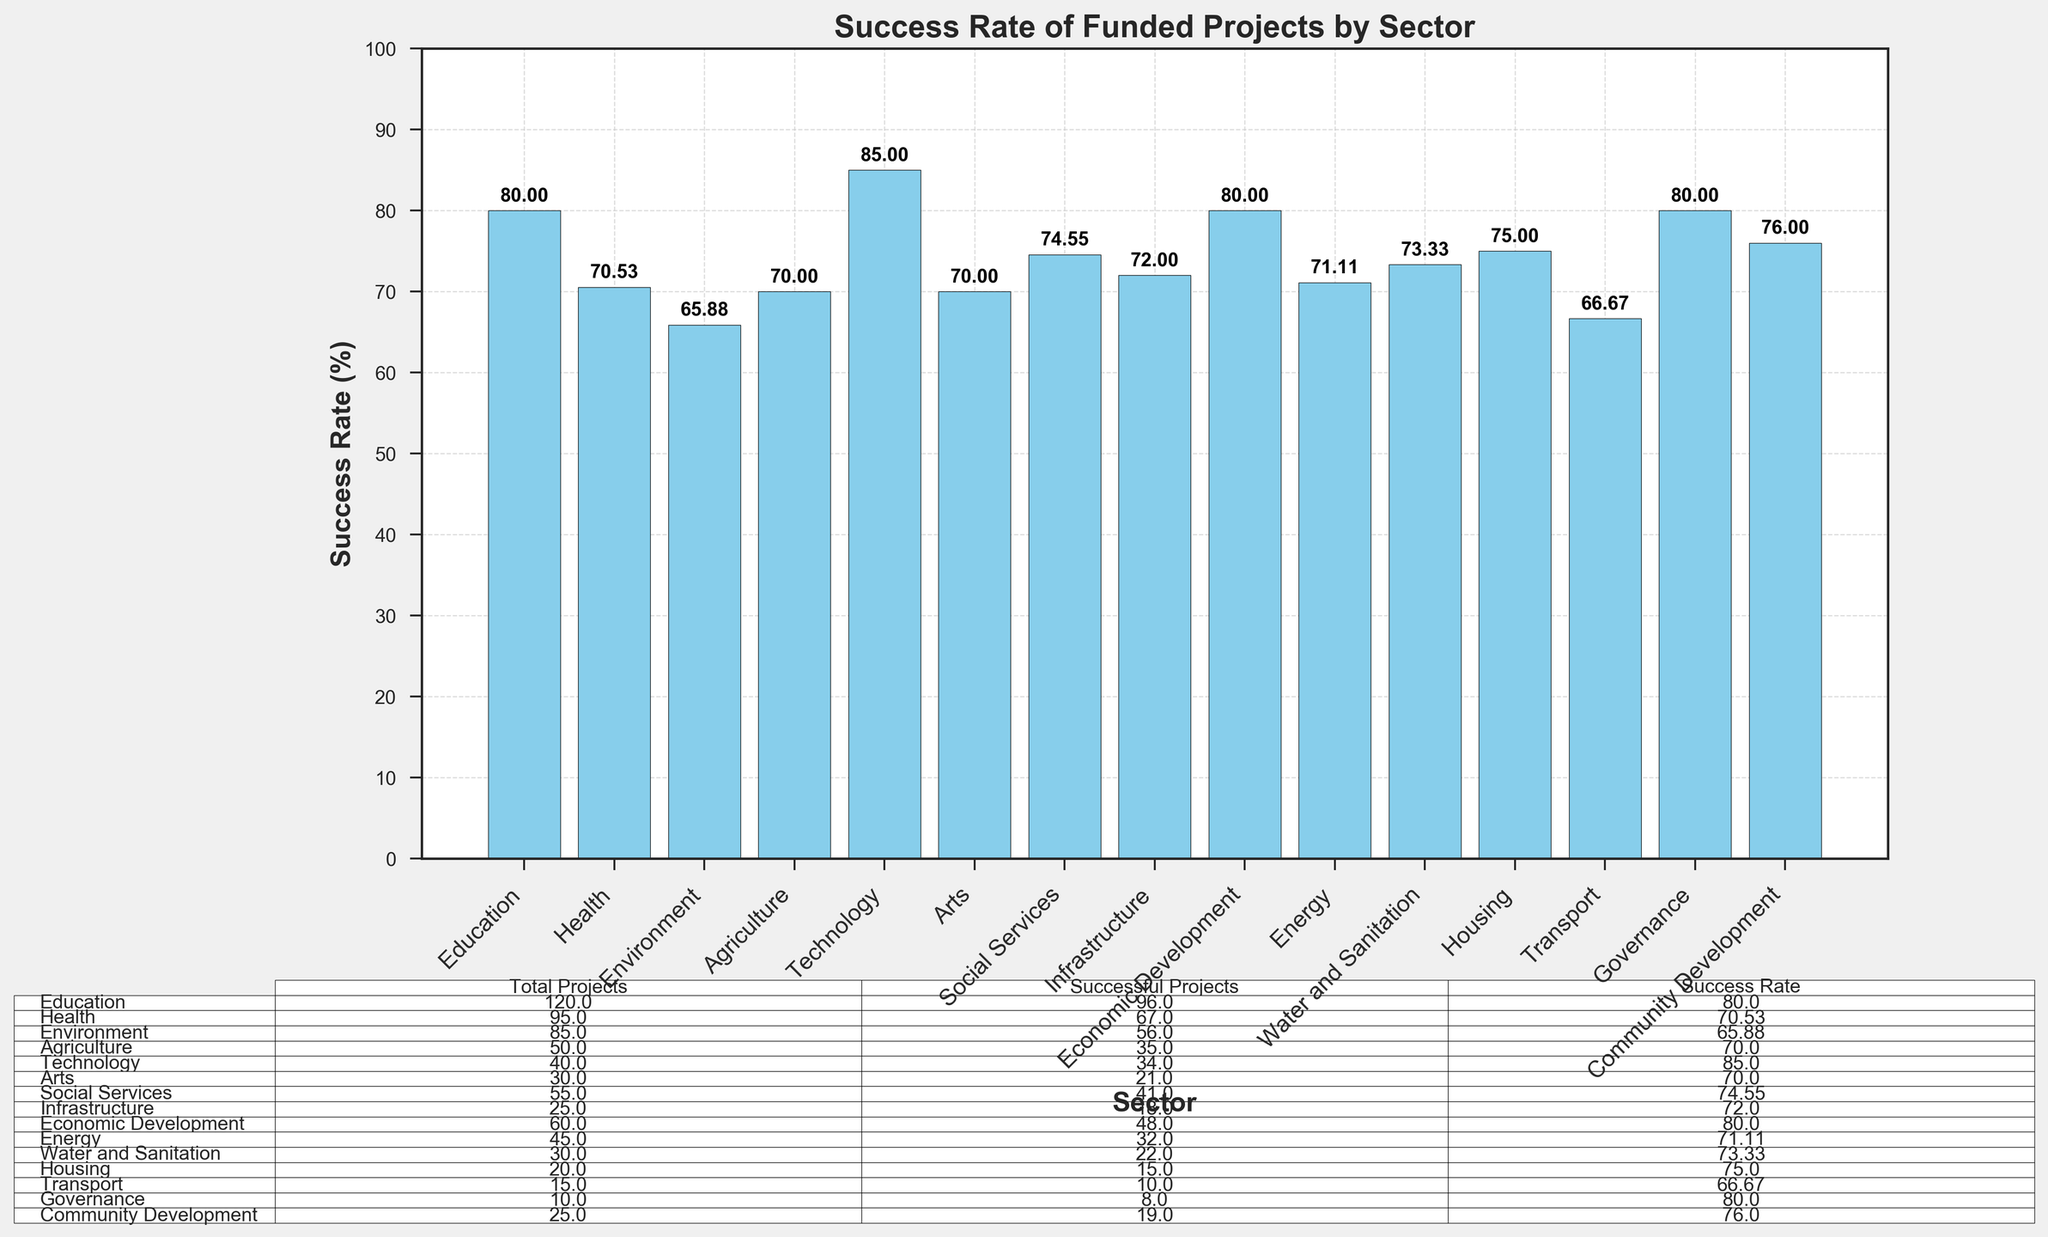What sector has the highest success rate? By examining the bar heights, "Technology" has the tallest bar, indicating it has the highest success rate of 85%.
Answer: Technology Which sector has the lowest success rate? By comparing the bar heights, "Environment" has the shortest bar, indicating the lowest success rate of 65.88%.
Answer: Environment What is the average success rate across all sectors? Sum the success rates of all sectors and divide by the number of sectors. Average = (80 + 70.53 + 65.88 + 70 + 85 + 70 + 74.55 + 72 + 80 + 71.11 + 73.33 + 75 + 66.67 + 80 + 76) / 15 ≈ 74.31%.
Answer: 74.31 How many sectors have a success rate above 75%? Counting the sectors with the success rates above 75%: Education (80%), Technology (85%), Economic Development (80%), Governance (80%), Community Development (76%). There are 5 sectors.
Answer: 5 Compare the success rate of sectors "Health" and "Energy" and determine which one is higher. The bar for "Health" shows a success rate of 70.53%, while "Energy" has 71.11%. Energy has a higher success rate than Health.
Answer: Energy Which two sectors have the most similar success rates? "Health" and "Agriculture" have very close success rates at 70.53% and 70%, respectively.
Answer: Health and Agriculture What is the total number of successful projects in "Transport" and "Housing" combined? "Transport" has 10 successful projects and "Housing" has 15. Total = 10 + 15 = 25.
Answer: 25 Which sector has a success rate closest to the median success rate of all sectors? To find the median, list all success rates: 65.88, 66.67, 70, 70, 70.53, 71.11, 72, 73.33, 74.55, 75, 76, 80, 80, 80, 85. The median is the 8th value: 73.33. "Water and Sanitation" has a success rate of 73.33%, closest to the median.
Answer: Water and Sanitation How many sectors have their success rates between 70% and 80%? Sectors with success rates in the range 70%-80%: Health (70.53%), Agriculture (70%), Arts (70%), Social Services (74.55%), Infrastructure (72%), Energy (71.11%), Water and Sanitation (73.33%), Housing (75), Community Development (76). There are 9 sectors.
Answer: 9 